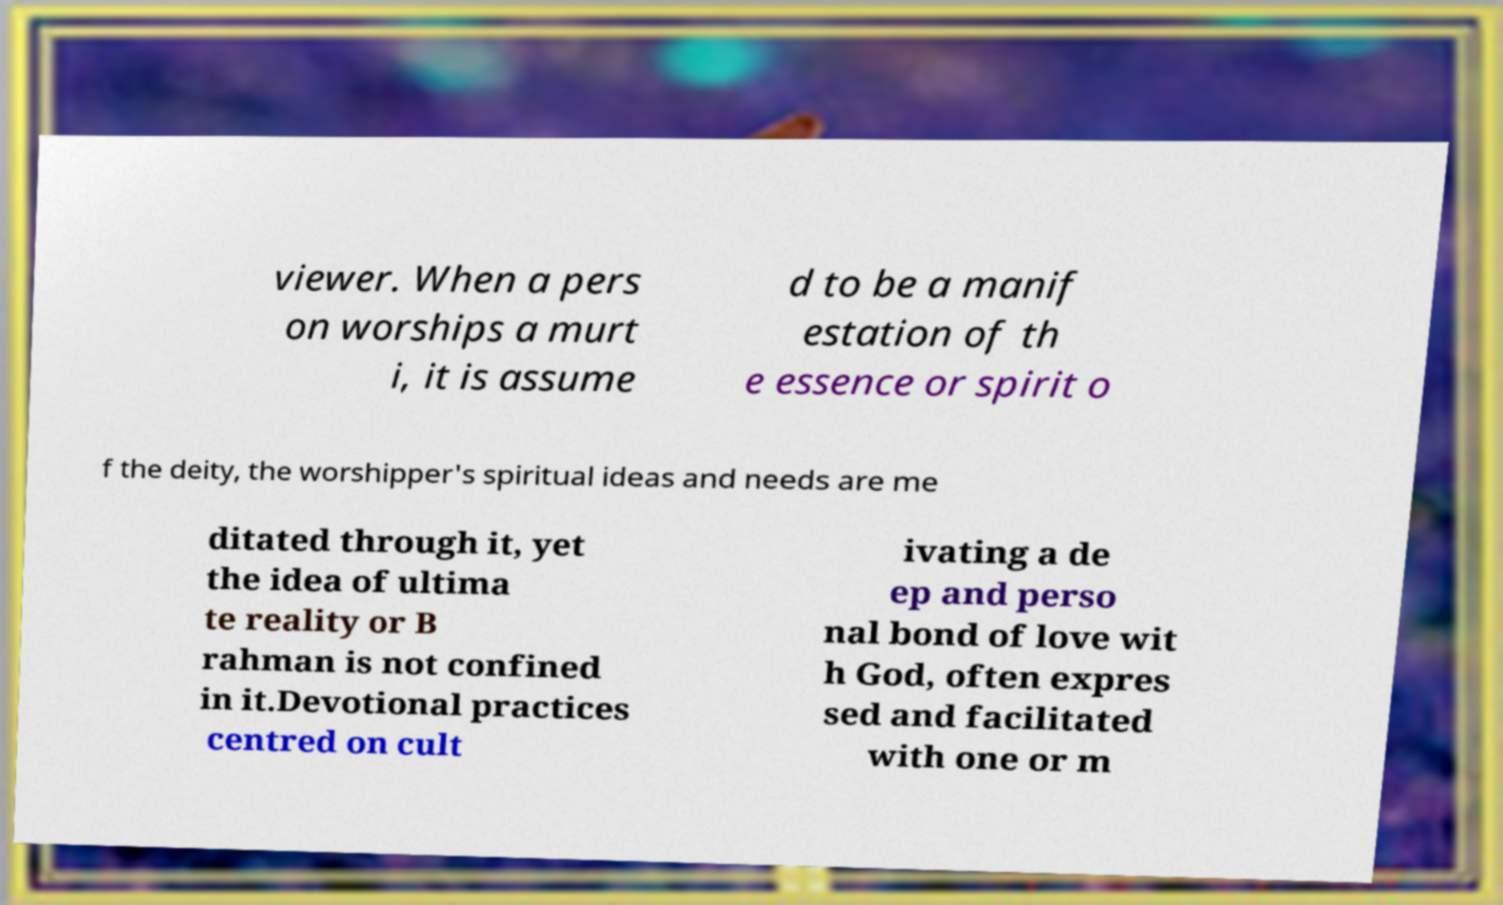Could you extract and type out the text from this image? viewer. When a pers on worships a murt i, it is assume d to be a manif estation of th e essence or spirit o f the deity, the worshipper's spiritual ideas and needs are me ditated through it, yet the idea of ultima te reality or B rahman is not confined in it.Devotional practices centred on cult ivating a de ep and perso nal bond of love wit h God, often expres sed and facilitated with one or m 